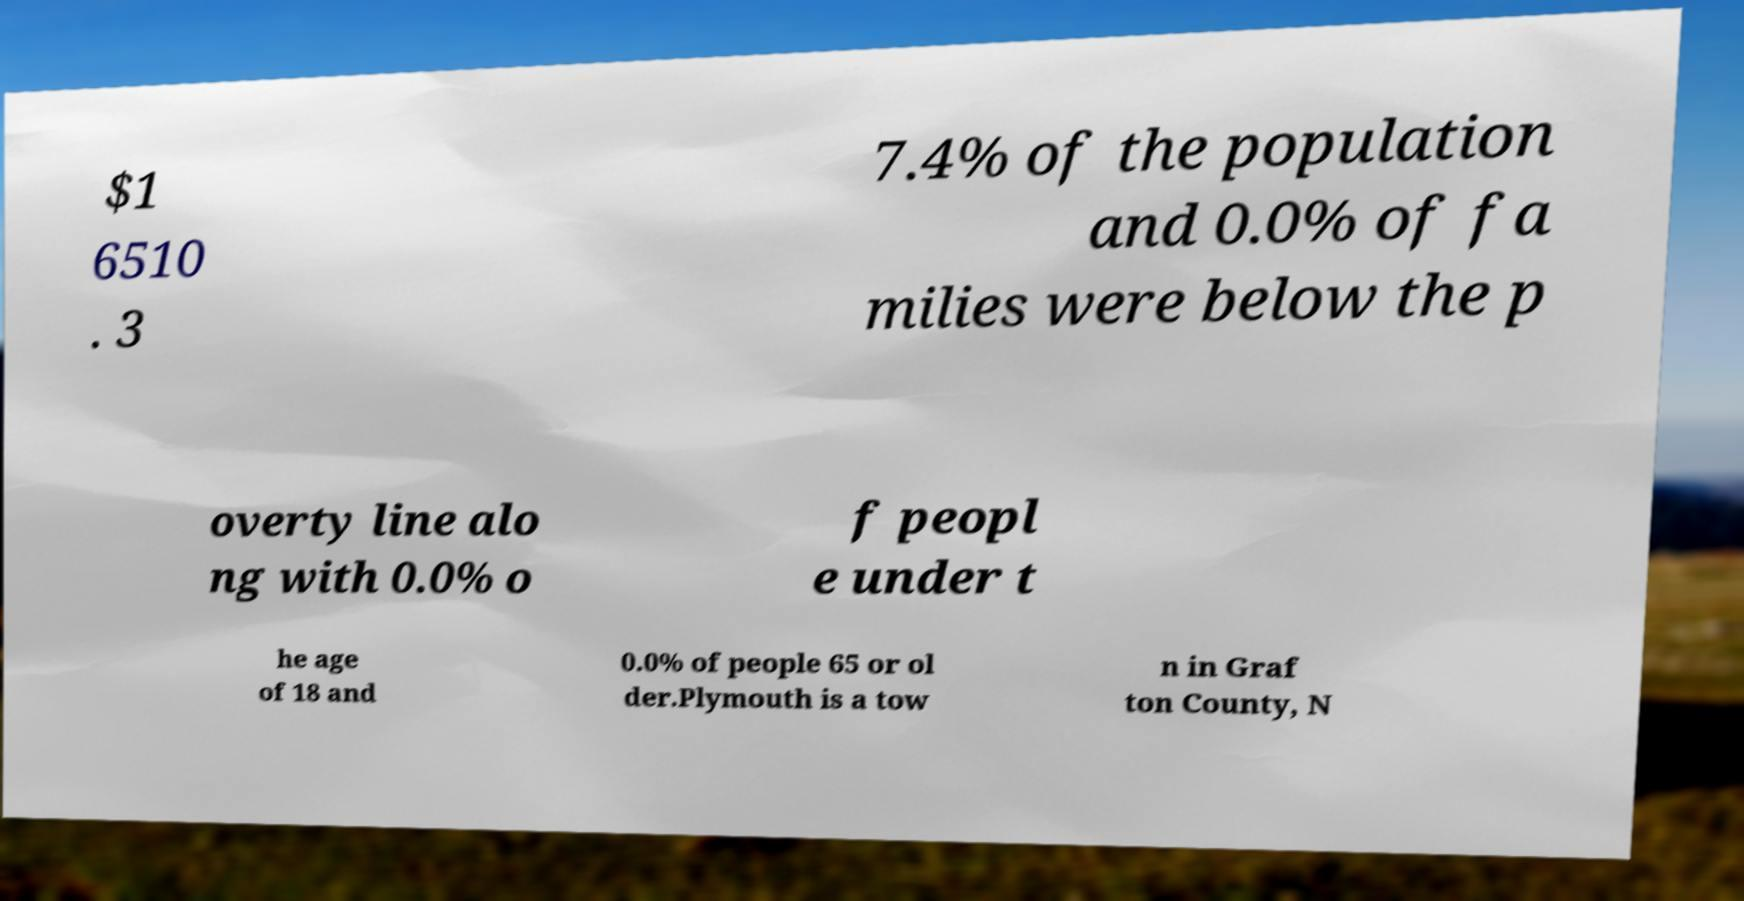Can you read and provide the text displayed in the image?This photo seems to have some interesting text. Can you extract and type it out for me? $1 6510 . 3 7.4% of the population and 0.0% of fa milies were below the p overty line alo ng with 0.0% o f peopl e under t he age of 18 and 0.0% of people 65 or ol der.Plymouth is a tow n in Graf ton County, N 